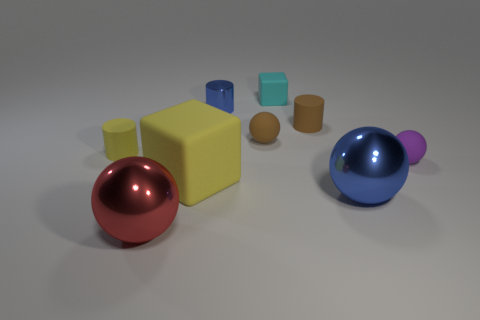Subtract all yellow cylinders. Subtract all red cubes. How many cylinders are left? 2 Add 1 big gray shiny balls. How many objects exist? 10 Subtract all balls. How many objects are left? 5 Subtract 0 green spheres. How many objects are left? 9 Subtract all big rubber blocks. Subtract all yellow cylinders. How many objects are left? 7 Add 1 matte cylinders. How many matte cylinders are left? 3 Add 4 small green balls. How many small green balls exist? 4 